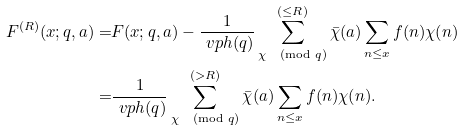<formula> <loc_0><loc_0><loc_500><loc_500>F ^ { ( R ) } ( x ; q , a ) = & F ( x ; q , a ) - \frac { 1 } { \ v p h ( q ) } \sum _ { \chi \pmod { q } } ^ { ( \leq R ) } \bar { \chi } ( a ) \sum _ { n \leq x } f ( n ) \chi ( n ) \\ = & \frac { 1 } { \ v p h ( q ) } \sum _ { \chi \pmod { q } } ^ { ( > R ) } \bar { \chi } ( a ) \sum _ { n \leq x } f ( n ) \chi ( n ) .</formula> 